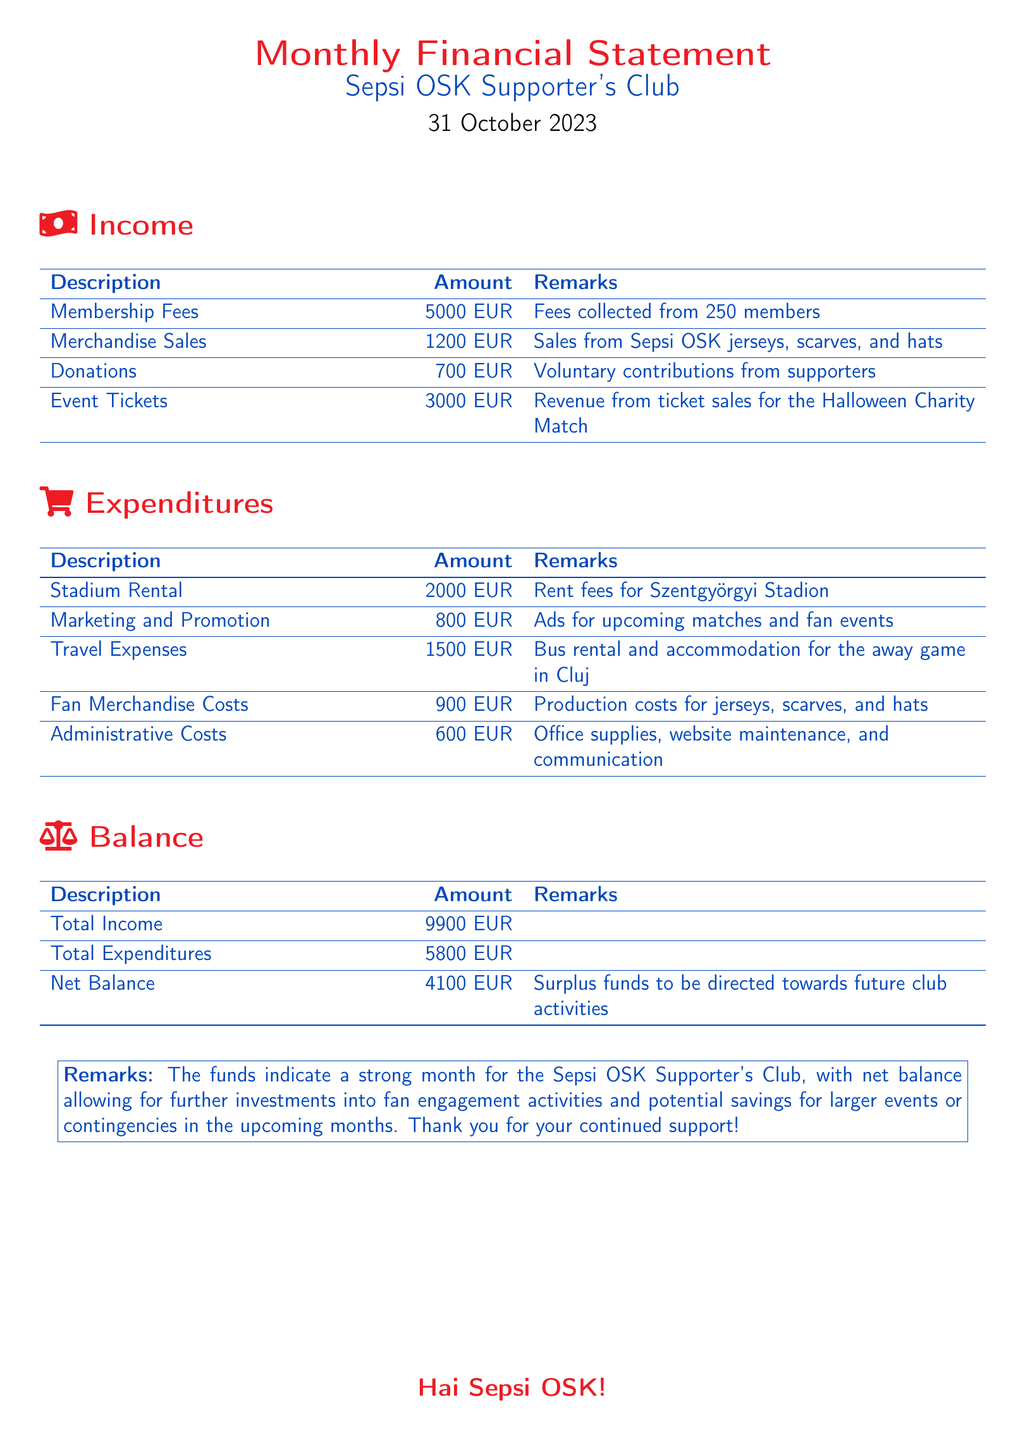What is the total income? The total income is gathered from various sources listed, including membership fees, merchandise sales, donations, and event tickets. The total calculated is 5000 EUR + 1200 EUR + 700 EUR + 3000 EUR = 9900 EUR.
Answer: 9900 EUR What is the amount spent on Stadium Rental? The document specifies the amount for stadium rental listed under expenditures. The stated amount is 2000 EUR.
Answer: 2000 EUR How much did the club earn from merchandise sales? The merchandise sales revenue is clearly stated in the income section of the document. It is listed as 1200 EUR.
Answer: 1200 EUR What is the net balance for the month? The net balance is calculated by subtracting total expenditures from total income, which is 9900 EUR - 5800 EUR = 4100 EUR.
Answer: 4100 EUR What were the administrative costs? Administrative costs are outlined in the expenditures section, showing the amount spent. The document lists this expense as 600 EUR.
Answer: 600 EUR How many members are contributing to the membership fees? The membership fees section indicates the number of contributing members who helped generate the total fee amount. There are 250 members.
Answer: 250 members What was the revenue from event tickets? The document lists a specific income source related to ticket sales for the Halloween Charity Match, stating the total revenue collected. The amount is 3000 EUR.
Answer: 3000 EUR What were the total expenditures for the month? Total expenditures encompass all costs related to the club's operations during the month, specifically listed in the document. The total is 5800 EUR.
Answer: 5800 EUR What is the main purpose of the surplus funds mentioned? The remarks section describes the intention behind the surplus funds, stating it will be directed towards future club activities and contingencies.
Answer: Future club activities 